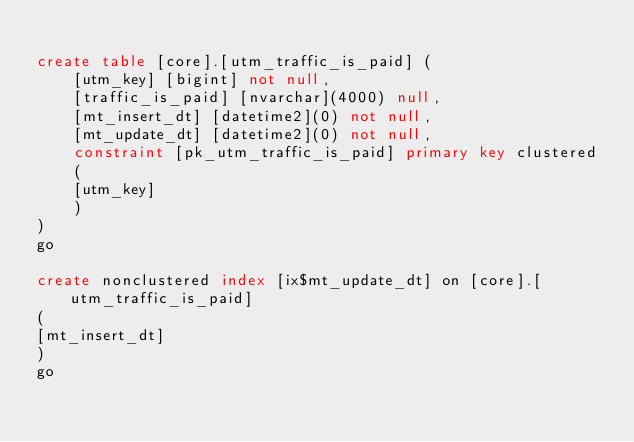<code> <loc_0><loc_0><loc_500><loc_500><_SQL_>
create table [core].[utm_traffic_is_paid] (
	[utm_key] [bigint] not null,
	[traffic_is_paid] [nvarchar](4000) null,
	[mt_insert_dt] [datetime2](0) not null,
	[mt_update_dt] [datetime2](0) not null,
	constraint [pk_utm_traffic_is_paid] primary key clustered
	(
	[utm_key]
	)
)
go

create nonclustered index [ix$mt_update_dt] on [core].[utm_traffic_is_paid]
(
[mt_insert_dt]
)
go
</code> 